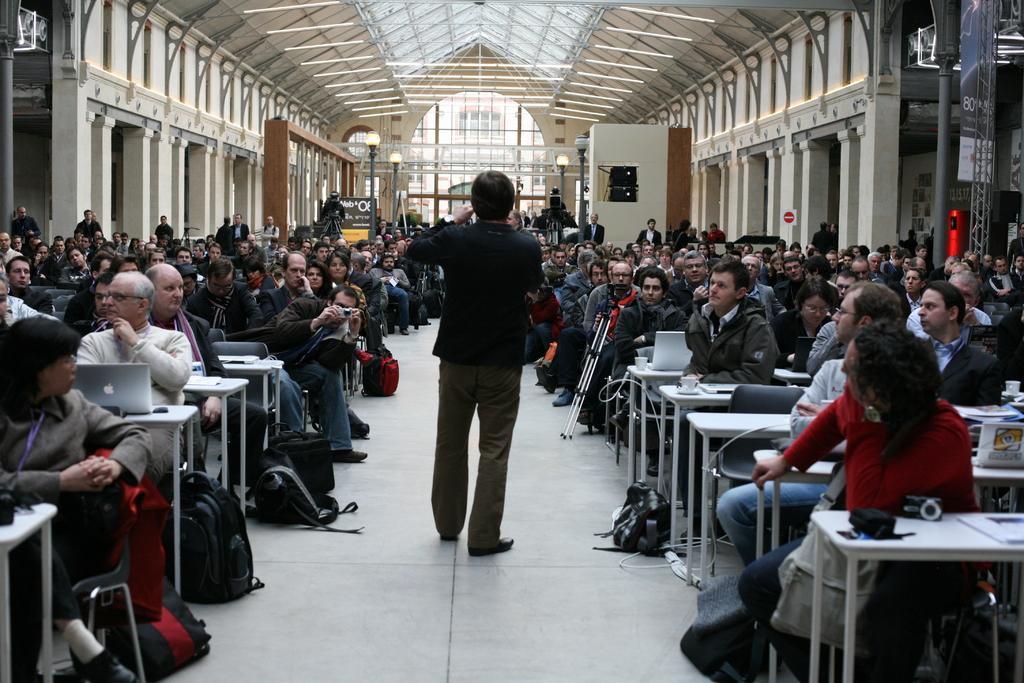Can you describe this image briefly? There are so many people sitting in a room and operating laptop. And there is another man standing in the middle. 